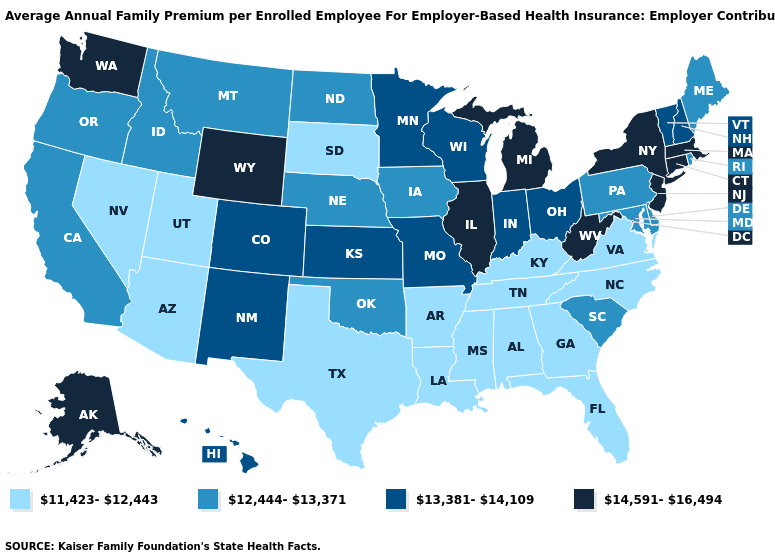Does South Dakota have the lowest value in the MidWest?
Concise answer only. Yes. How many symbols are there in the legend?
Be succinct. 4. What is the value of South Dakota?
Be succinct. 11,423-12,443. What is the lowest value in the USA?
Keep it brief. 11,423-12,443. Name the states that have a value in the range 14,591-16,494?
Give a very brief answer. Alaska, Connecticut, Illinois, Massachusetts, Michigan, New Jersey, New York, Washington, West Virginia, Wyoming. What is the highest value in the USA?
Keep it brief. 14,591-16,494. Name the states that have a value in the range 12,444-13,371?
Short answer required. California, Delaware, Idaho, Iowa, Maine, Maryland, Montana, Nebraska, North Dakota, Oklahoma, Oregon, Pennsylvania, Rhode Island, South Carolina. What is the value of Texas?
Write a very short answer. 11,423-12,443. Does Massachusetts have a lower value than Alabama?
Answer briefly. No. Name the states that have a value in the range 13,381-14,109?
Be succinct. Colorado, Hawaii, Indiana, Kansas, Minnesota, Missouri, New Hampshire, New Mexico, Ohio, Vermont, Wisconsin. Does the map have missing data?
Be succinct. No. What is the value of Montana?
Give a very brief answer. 12,444-13,371. What is the lowest value in states that border Texas?
Quick response, please. 11,423-12,443. 